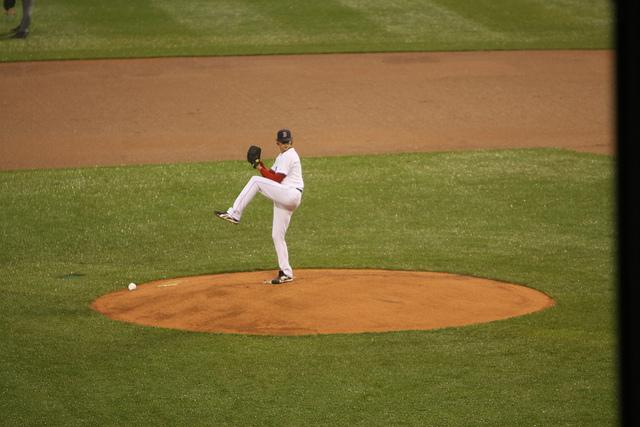Is the pitcher right or left handed?
Answer briefly. Right. What team is the pitcher playing for?
Be succinct. Red sox. Is the man throwing a pitch?
Concise answer only. Yes. How many athletes are pictured here?
Answer briefly. 1. Is there 2 balls on the ground?
Be succinct. No. What game is he playing?
Answer briefly. Baseball. 